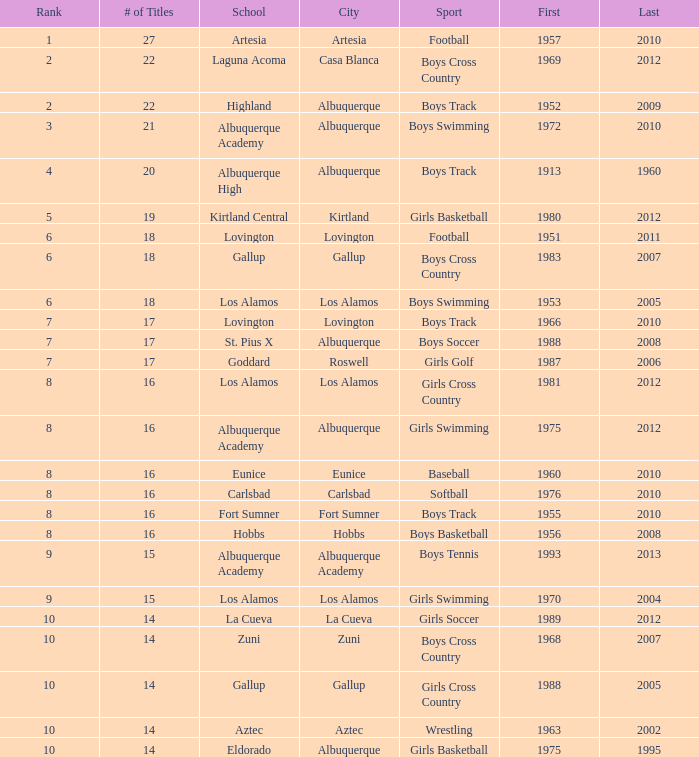What is the top position held by the boys' swimming team in albuquerque? 3.0. 